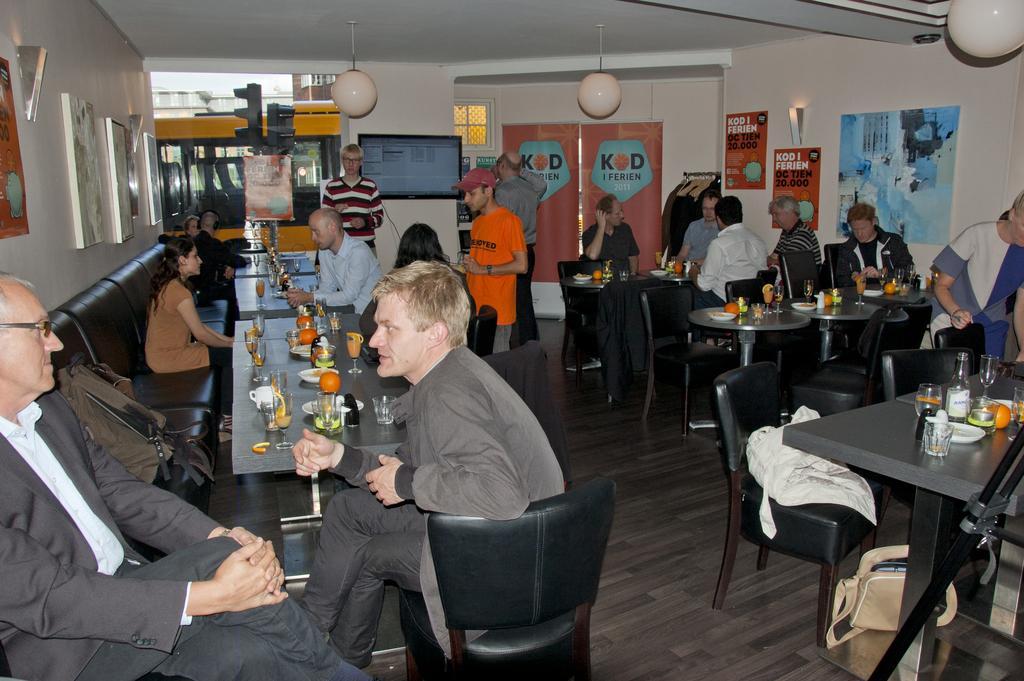How would you summarize this image in a sentence or two? In this image we can see a group of people are sitting on the chair, and in front here is the table and plates and glasses and bottles and some objects on it, and here is the wall and photo frame on it, and and here is the television, and here is the door. 